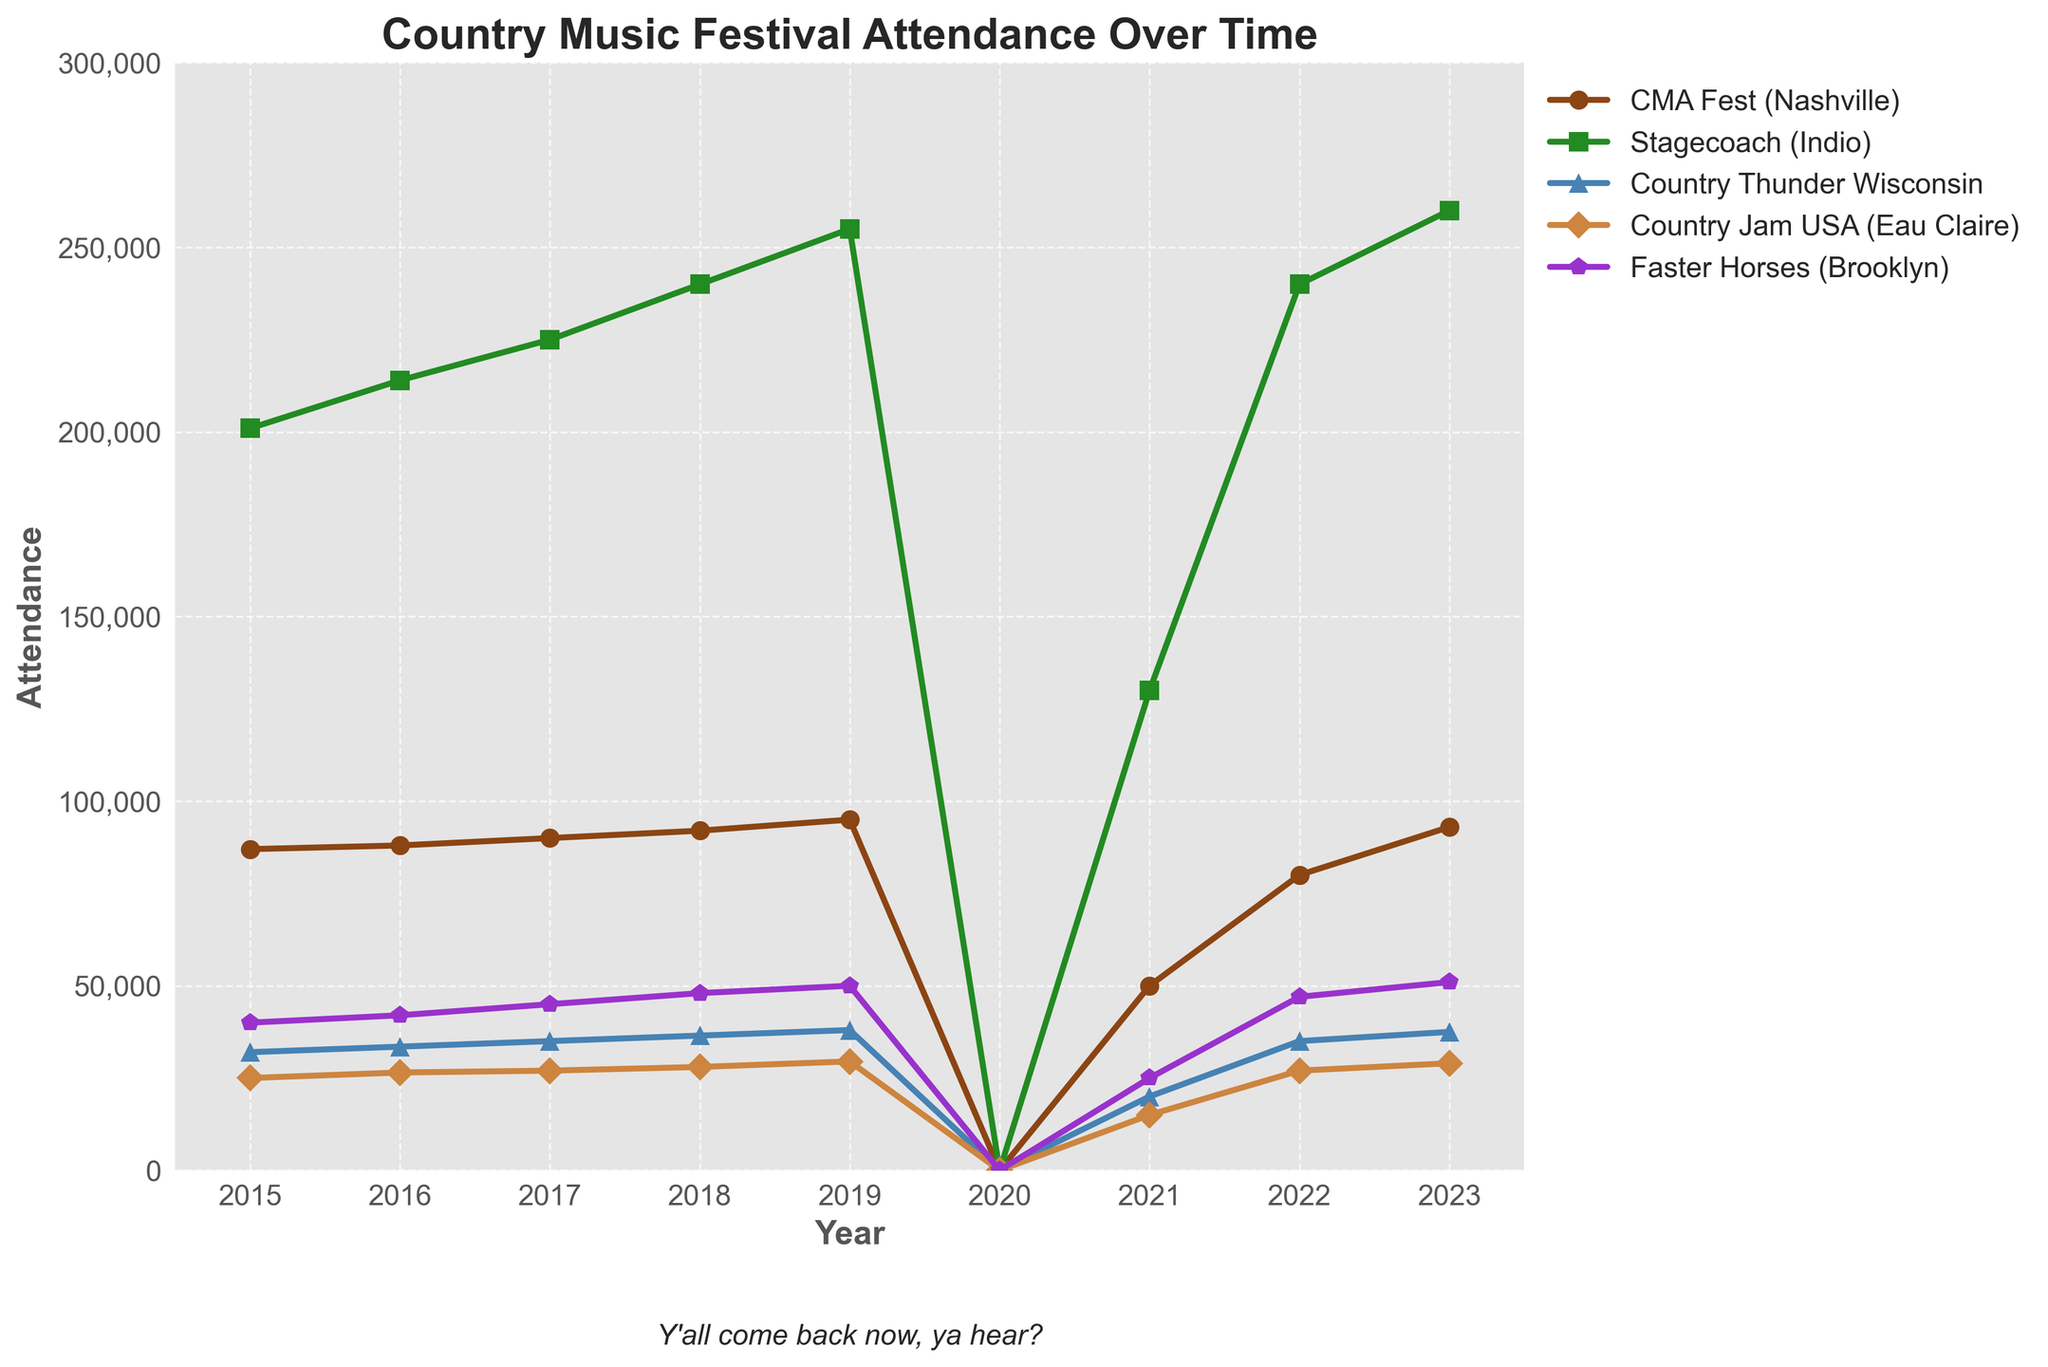What's the trend in attendance at CMA Fest (Nashville) from 2015 to 2023? To determine the trend, one can observe the line for CMA Fest (Nashville) in the plot. It shows a generally increasing trend, except for a dip in 2020 and 2021 due to likely reasons like the pandemic, then it recovers and rises again in 2022 and 2023.
Answer: Increasing trend with a dip in 2020 and 2021 Which festival had the highest attendance in 2023? By looking at the peaks of all lines for the year 2023, we can see that Stagecoach (Indio) had the highest attendance compared to the other festivals.
Answer: Stagecoach (Indio) How did the attendance of Faster Horses (Brooklyn) in 2021 compare to its attendance in 2019? To compare the attendance, examine the points on the graph for Faster Horses (Brooklyn) in 2019 and 2021. The attendance in 2019 was 50,000, while in 2021, it dropped to 25,000.
Answer: Attendance in 2021 was less by 25,000 compared to 2019 Which festival had the most significant drop in attendance from 2019 to 2021? Check the vertical distance between the points for 2019 and 2021 for each festival. Stagecoach (Indio) shows the most significant drop, from 255,000 in 2019 to 130,000 in 2021.
Answer: Stagecoach (Indio) What's the average attendance at Country Thunder Wisconsin across the available years excluding 2020? Exclude the year 2020 and calculate the average: (32000 + 33500 + 35000 + 36500 + 38000 + 20000 + 35000 + 37500) / 8 = 33,375.
Answer: 33,375 Compare the attendance changes for CMA Fest (Nashville) and Faster Horses (Brooklyn) between 2022 and 2023. Which one saw a higher increase? Calculate the difference for each festival. CMA Fest: 93,000 - 80,000 = 13,000. Faster Horses: 51,000 - 47,000 = 4,000. CMA Fest had a higher increase.
Answer: CMA Fest (Nashville) In what year did Country Jam USA (Eau Claire) see its highest attendance, and what was the attendance figure? Locate the peak point on the line for Country Jam USA (Eau Claire). The highest attendance was in 2023 with 29,000.
Answer: 2023, 29,000 What's the total combined attendance for all festivals in 2017? Add the attendance for all festivals in 2017: 90,000 (CMA Fest) + 225,000 (Stagecoach) + 35,000 (Country Thunder Wisconsin) + 27,000 (Country Jam USA) + 45,000 (Faster Horses) = 422,000.
Answer: 422,000 Which festival had a continuously increasing attendance from 2015 to 2023, skipping 2020? Check each festival's line, ignoring 2020. Stagecoach (Indio) has attendance increasing every year apart from the dip in 2020.
Answer: Stagecoach (Indio) 